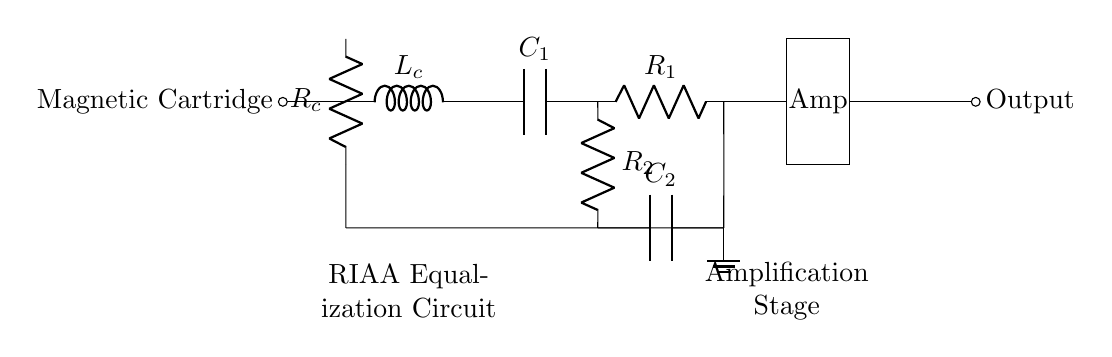What is the component type at the beginning of the circuit? The circuit begins with a magnetic cartridge, which is typically used to convert the mechanical movement of the stylus into an electrical signal.
Answer: Magnetic Cartridge What type of circuit does this diagram represent? The circuit represents an RIAA equalization circuit, which is specifically designed to optimize the playback of vinyl records by compensating for frequency response.
Answer: RIAA Equalization How many resistors are present in the circuit? There are two resistors present; R1 and R2 are both indicated in the circuit diagram.
Answer: 2 What is the purpose of the capacitors in the circuit? The capacitors, C1 and C2, are part of the RIAA equalization process, which helps to filter frequencies to match the characteristics required for vinyl playback.
Answer: RIAA Equalization What connects the output to the amplifier? A direct connection with no additional components connects the output to the amplifier, allowing the signal to flow directly from the RIAA equalization to the amplifier stage.
Answer: Short connection Which component grounds the circuit? The ground in the diagram is connected to the junction of the resistors and capacitors, providing a reference point for the entire circuit.
Answer: Ground What is the order of components starting from the magnetic cartridge? The order is magnetic cartridge, resistance R_c, inductance L_c, followed by capacitors and resistors of the RIAA equalization, and finally the amplifier.
Answer: Magnetic cartridge, R_c, L_c, C1, R1, R2, C2, Amp 